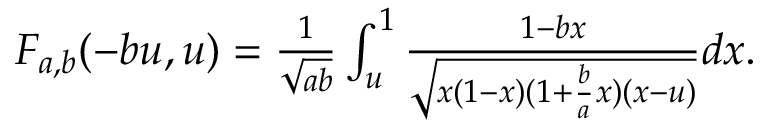Convert formula to latex. <formula><loc_0><loc_0><loc_500><loc_500>\begin{array} { r } { F _ { a , b } ( - b u , u ) = \frac { 1 } { \sqrt { a b } } \int _ { u } ^ { 1 } \frac { 1 - b x } { \sqrt { x ( 1 - x ) ( 1 + \frac { b } { a } x ) ( x - u ) } } d x . } \end{array}</formula> 